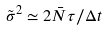Convert formula to latex. <formula><loc_0><loc_0><loc_500><loc_500>\tilde { \sigma } ^ { 2 } \simeq 2 \bar { N } \tau / \Delta t</formula> 